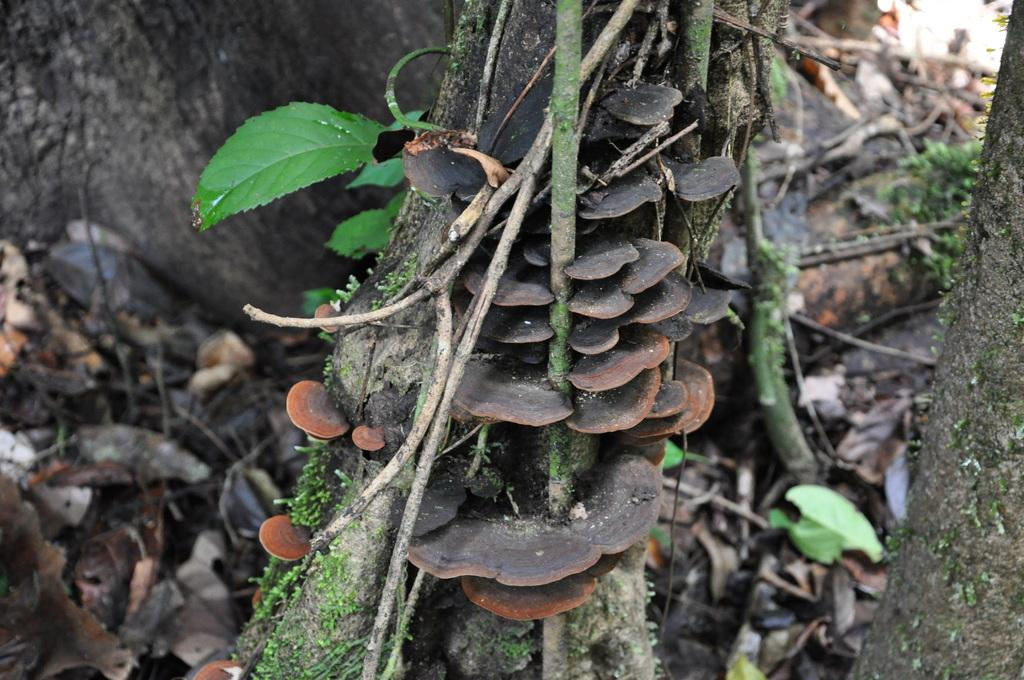What type of vegetation is present in the image? There are green leaves and mushrooms in the image. What else can be seen on the ground in the image? There are dried leaves on the ground in the image. What color are the eyes of the ornament in the image? There is no ornament present in the image, and therefore no eyes to describe. 